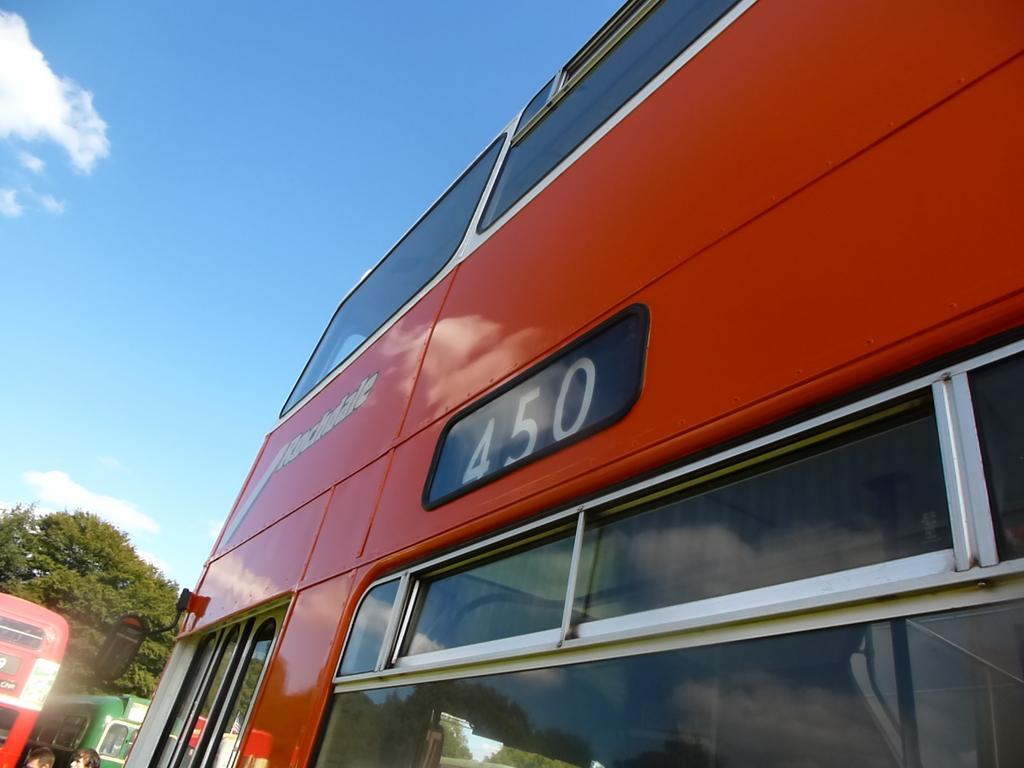Could you give a brief overview of what you see in this image? In this picture we can see three buses, in the background there is a tree, we can see two persons at the left bottom, there is the sky at the top of the picture. 